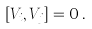<formula> <loc_0><loc_0><loc_500><loc_500>[ V _ { i } , V _ { j } ] = 0 \, .</formula> 